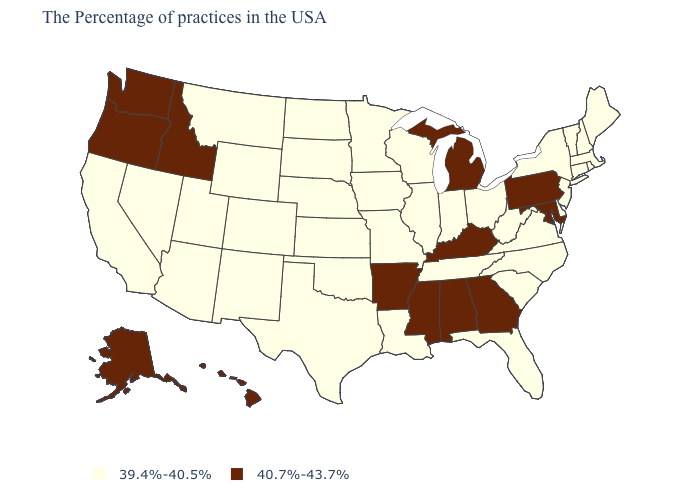Name the states that have a value in the range 39.4%-40.5%?
Write a very short answer. Maine, Massachusetts, Rhode Island, New Hampshire, Vermont, Connecticut, New York, New Jersey, Delaware, Virginia, North Carolina, South Carolina, West Virginia, Ohio, Florida, Indiana, Tennessee, Wisconsin, Illinois, Louisiana, Missouri, Minnesota, Iowa, Kansas, Nebraska, Oklahoma, Texas, South Dakota, North Dakota, Wyoming, Colorado, New Mexico, Utah, Montana, Arizona, Nevada, California. What is the value of Tennessee?
Concise answer only. 39.4%-40.5%. Name the states that have a value in the range 39.4%-40.5%?
Short answer required. Maine, Massachusetts, Rhode Island, New Hampshire, Vermont, Connecticut, New York, New Jersey, Delaware, Virginia, North Carolina, South Carolina, West Virginia, Ohio, Florida, Indiana, Tennessee, Wisconsin, Illinois, Louisiana, Missouri, Minnesota, Iowa, Kansas, Nebraska, Oklahoma, Texas, South Dakota, North Dakota, Wyoming, Colorado, New Mexico, Utah, Montana, Arizona, Nevada, California. Name the states that have a value in the range 39.4%-40.5%?
Concise answer only. Maine, Massachusetts, Rhode Island, New Hampshire, Vermont, Connecticut, New York, New Jersey, Delaware, Virginia, North Carolina, South Carolina, West Virginia, Ohio, Florida, Indiana, Tennessee, Wisconsin, Illinois, Louisiana, Missouri, Minnesota, Iowa, Kansas, Nebraska, Oklahoma, Texas, South Dakota, North Dakota, Wyoming, Colorado, New Mexico, Utah, Montana, Arizona, Nevada, California. Which states hav the highest value in the South?
Concise answer only. Maryland, Georgia, Kentucky, Alabama, Mississippi, Arkansas. Name the states that have a value in the range 40.7%-43.7%?
Be succinct. Maryland, Pennsylvania, Georgia, Michigan, Kentucky, Alabama, Mississippi, Arkansas, Idaho, Washington, Oregon, Alaska, Hawaii. What is the value of Montana?
Concise answer only. 39.4%-40.5%. What is the value of Rhode Island?
Write a very short answer. 39.4%-40.5%. Which states hav the highest value in the Northeast?
Concise answer only. Pennsylvania. Name the states that have a value in the range 40.7%-43.7%?
Answer briefly. Maryland, Pennsylvania, Georgia, Michigan, Kentucky, Alabama, Mississippi, Arkansas, Idaho, Washington, Oregon, Alaska, Hawaii. What is the value of Ohio?
Keep it brief. 39.4%-40.5%. What is the lowest value in the USA?
Concise answer only. 39.4%-40.5%. Name the states that have a value in the range 39.4%-40.5%?
Give a very brief answer. Maine, Massachusetts, Rhode Island, New Hampshire, Vermont, Connecticut, New York, New Jersey, Delaware, Virginia, North Carolina, South Carolina, West Virginia, Ohio, Florida, Indiana, Tennessee, Wisconsin, Illinois, Louisiana, Missouri, Minnesota, Iowa, Kansas, Nebraska, Oklahoma, Texas, South Dakota, North Dakota, Wyoming, Colorado, New Mexico, Utah, Montana, Arizona, Nevada, California. What is the lowest value in the USA?
Write a very short answer. 39.4%-40.5%. How many symbols are there in the legend?
Quick response, please. 2. 